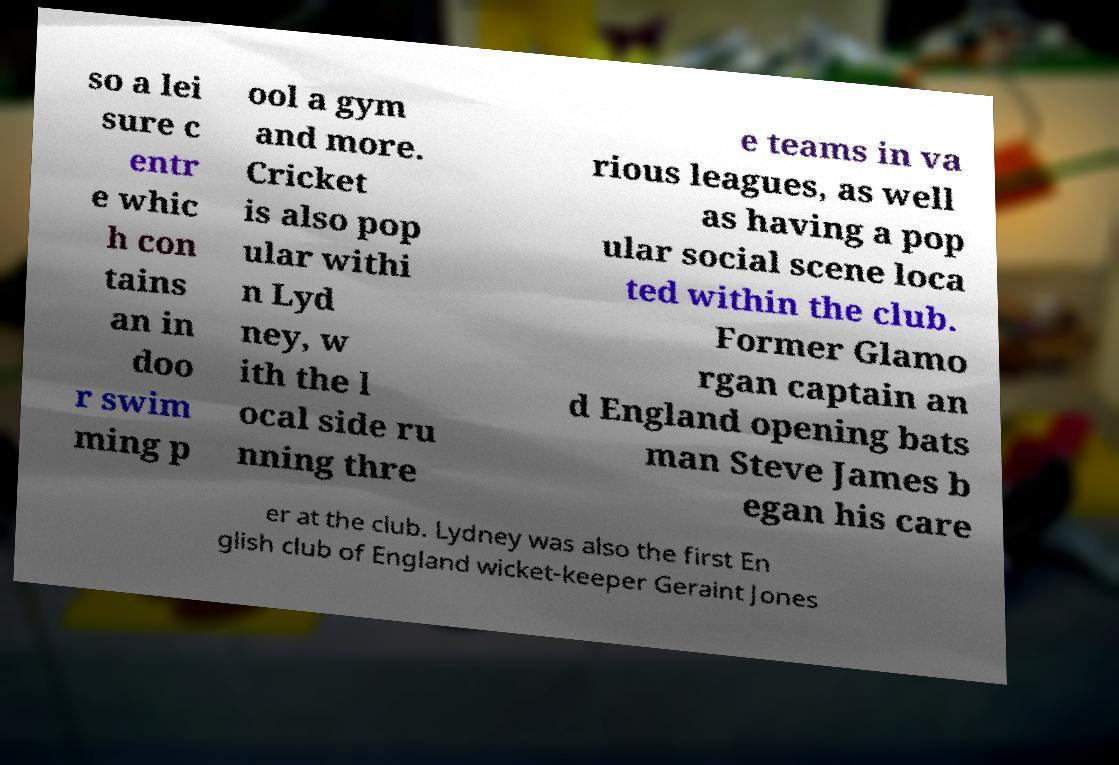There's text embedded in this image that I need extracted. Can you transcribe it verbatim? so a lei sure c entr e whic h con tains an in doo r swim ming p ool a gym and more. Cricket is also pop ular withi n Lyd ney, w ith the l ocal side ru nning thre e teams in va rious leagues, as well as having a pop ular social scene loca ted within the club. Former Glamo rgan captain an d England opening bats man Steve James b egan his care er at the club. Lydney was also the first En glish club of England wicket-keeper Geraint Jones 